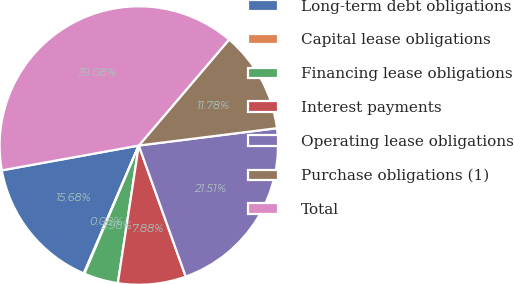Convert chart. <chart><loc_0><loc_0><loc_500><loc_500><pie_chart><fcel>Long-term debt obligations<fcel>Capital lease obligations<fcel>Financing lease obligations<fcel>Interest payments<fcel>Operating lease obligations<fcel>Purchase obligations (1)<fcel>Total<nl><fcel>15.68%<fcel>0.08%<fcel>3.98%<fcel>7.88%<fcel>21.51%<fcel>11.78%<fcel>39.08%<nl></chart> 